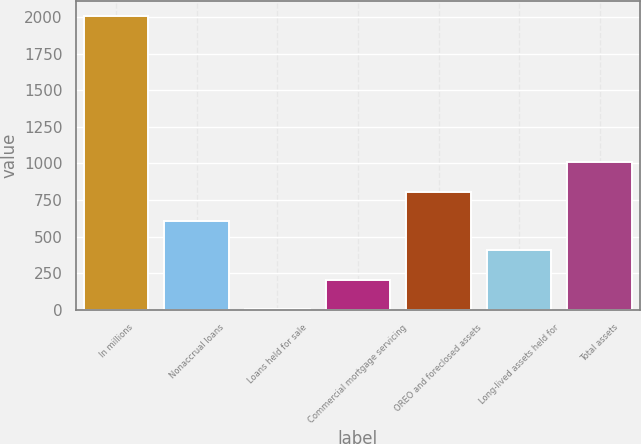<chart> <loc_0><loc_0><loc_500><loc_500><bar_chart><fcel>In millions<fcel>Nonaccrual loans<fcel>Loans held for sale<fcel>Commercial mortgage servicing<fcel>OREO and foreclosed assets<fcel>Long-lived assets held for<fcel>Total assets<nl><fcel>2012<fcel>606.4<fcel>4<fcel>204.8<fcel>807.2<fcel>405.6<fcel>1008<nl></chart> 